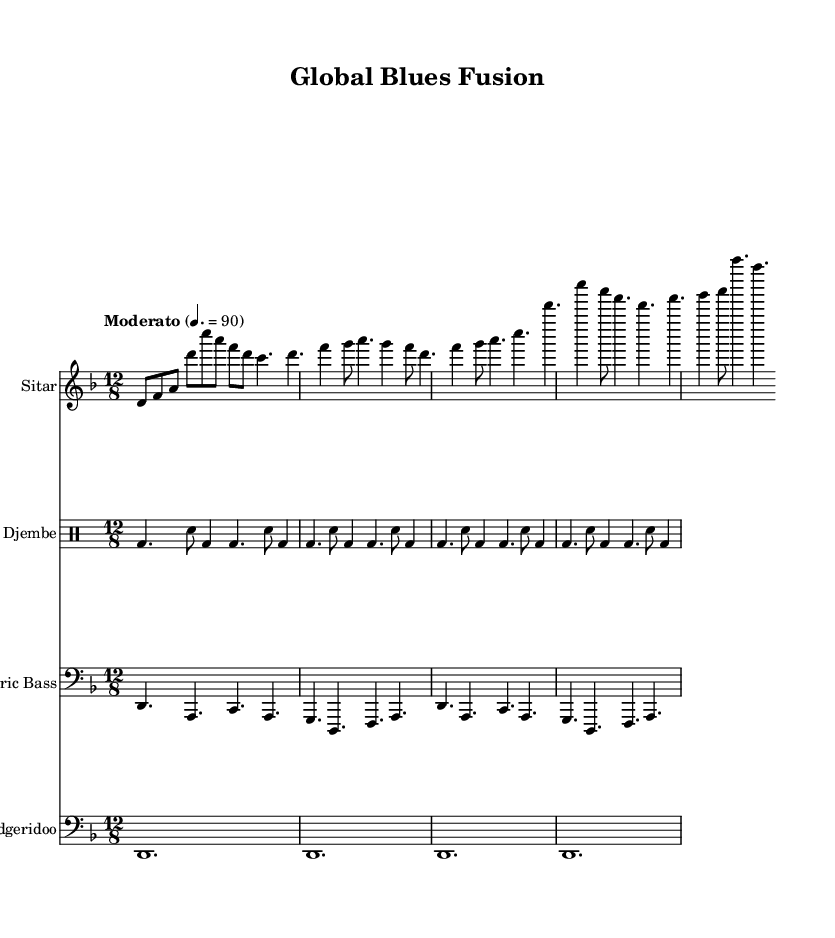What is the key signature of this music? The key signature is D minor, which has one flat (B flat). This can be determined by looking at the key signature indicated at the beginning of the staff, which indicates a minor key.
Answer: D minor What is the time signature of this music? The time signature is 12/8, which indicates a compound quadruple meter. This can be found at the beginning of the score where the time signature is written.
Answer: 12/8 What is the tempo marking for this piece? The tempo marking is marked "Moderato" with a metronome indication of 90 beats per minute. This information is typically located at the start of the piece and provides guidance on the speed of the music.
Answer: Moderato, 90 How many measures are in the sitar part? The sitar part consists of 4 measures. By counting the distinct segments of music, separated by the bar lines, we can find the total number of measures present in the score.
Answer: 4 Which unconventional instrument is featured alongside traditional blues instruments? The unconventional instrument featured is the didgeridoo, which is commonly associated with Australian Aboriginal music. Its presence in the score is indicated by the specific staff for it, showcasing its unique sound in this fusion piece.
Answer: Didgeridoo In what style is this music primarily composed? This music is primarily composed in the style of Blues, as indicated by the structure and instrumentation that are characteristic of the genre. The incorporation of world music influences and various instruments also reflects an experimental approach within the blues framework.
Answer: Experimental Blues 